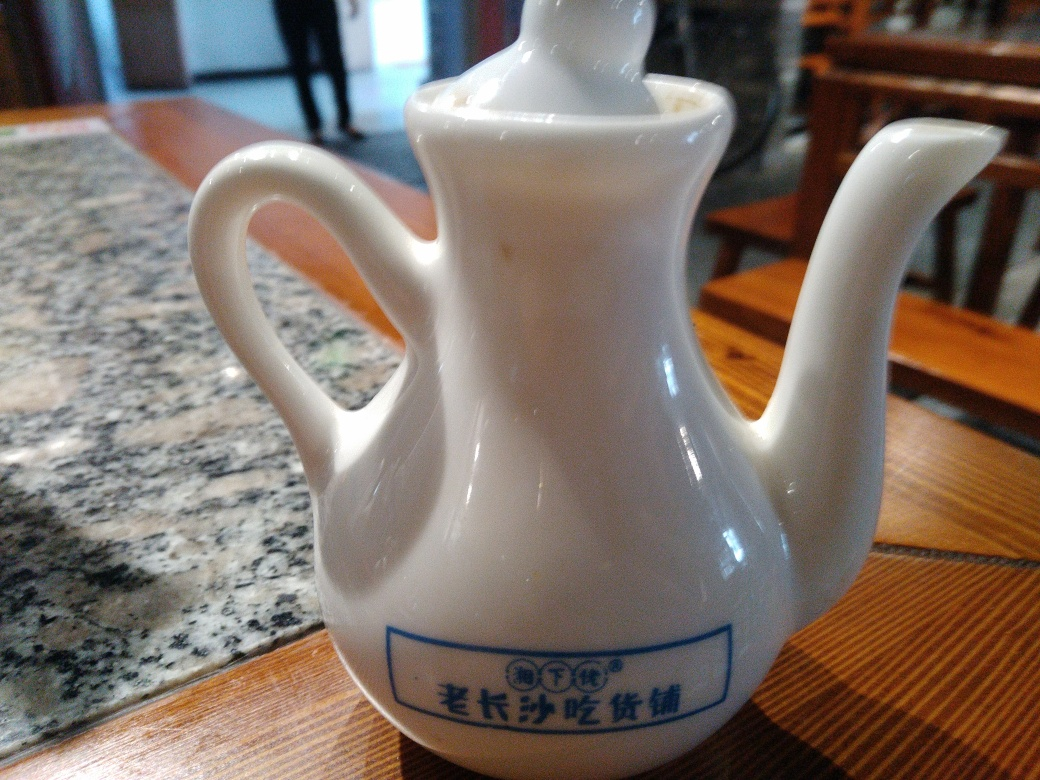What cultural significance could this type of teapot hold? Teapots of this kind are deeply rooted in the tea-drinking traditions of many cultures, particularly in countries like China, where the practice of tea-making and serving has historical and ceremonial importance. The design of such teapots is not just functional but is also imbued with aesthetic and cultural values, often reflecting the artistry and heritage of the region it originates from. 